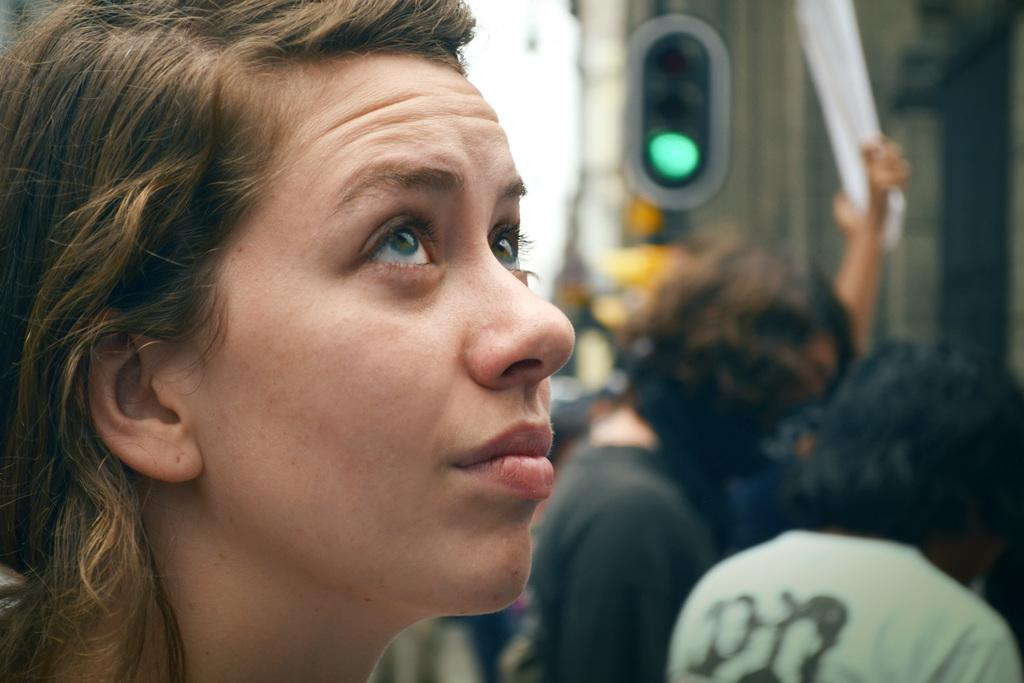Who is the main subject in the image? There is a girl in the image. Are there any other people present in the image? Yes, there are people standing beside the girl. Can you describe the background of the image? The background of the image is blurred. How many clocks can be seen on the girl's knee in the image? There are no clocks visible on the girl's knee in the image. 